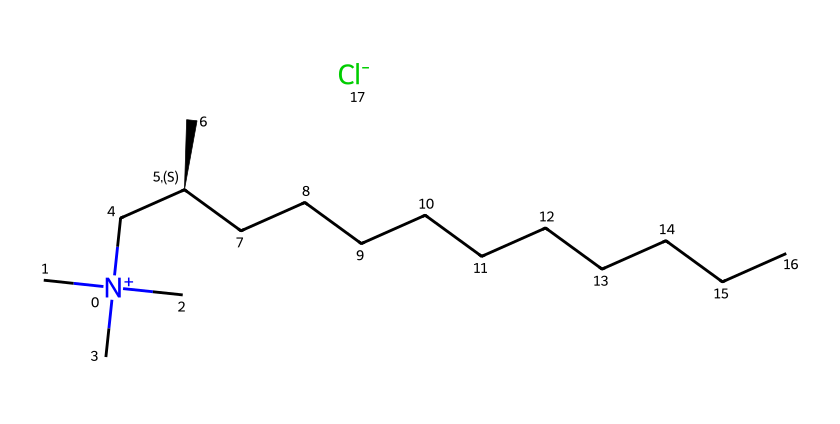What is the chemical name represented by this SMILES? The SMILES representation describes the chemical structure of alkyl dimethyl benzyl ammonium chloride, a quaternary ammonium compound noted for its disinfectant properties.
Answer: alkyl dimethyl benzyl ammonium chloride How many carbon atoms are in the structure? Analyzing the SMILES, the structure contains a long carbon chain (specifically in the "CCCCCCCCCC" portion) and branches, which results in a total of 17 carbon atoms.
Answer: 17 What type of chemical compound is this? The presence of a quaternary ammonium center (the nitrogen bonded to four carbon atoms) indicates that this is classified as a quaternary ammonium compound.
Answer: quaternary ammonium compound What is the charge of the nitrogen atom in this compound? In the SMILES, the nitrogen symbol "[N+]" indicates that the nitrogen atom has a positive charge as it is attached to four organic groups.
Answer: positive How does this compound function in disinfectants? Alkyl dimethyl benzyl ammonium chloride functions as a surfactant, effectively interacting with cell membranes of microorganisms, resulting in their disruption and subsequent inactivation.
Answer: surfactant Which functional groups are present in this compound? The structure contains a quaternary ammonium group and a long alkyl chain, both characteristic of surfactants and disinfectants.
Answer: quaternary ammonium, alkyl chain What is the significance of the chloride in this compound? The chloride ion serves as a counterion, balancing the charge of the quaternary ammonium, crucial for the stability and solubility of the compound in solutions.
Answer: counterion 